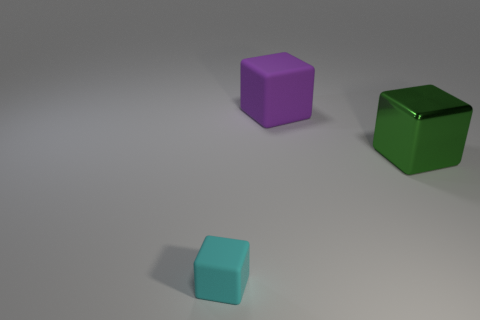What number of cubes are in front of the large matte object and to the left of the green shiny cube?
Your answer should be very brief. 1. There is a matte cube behind the cyan thing; what is its size?
Your response must be concise. Large. How many other objects are there of the same color as the big metal cube?
Ensure brevity in your answer.  0. What material is the large object behind the big thing in front of the purple matte cube?
Your response must be concise. Rubber. There is a matte block on the right side of the tiny cyan object; is it the same color as the big shiny thing?
Offer a terse response. No. Are there any other things that are the same material as the big purple block?
Provide a succinct answer. Yes. What number of large green shiny things have the same shape as the small rubber object?
Your response must be concise. 1. There is a cyan thing that is the same material as the big purple thing; what is its size?
Your response must be concise. Small. Are there any green metallic things on the left side of the big object that is behind the thing on the right side of the large purple block?
Give a very brief answer. No. There is a block left of the purple matte cube; is it the same size as the big purple object?
Offer a very short reply. No. 